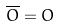<formula> <loc_0><loc_0><loc_500><loc_500>\overline { O } = O</formula> 